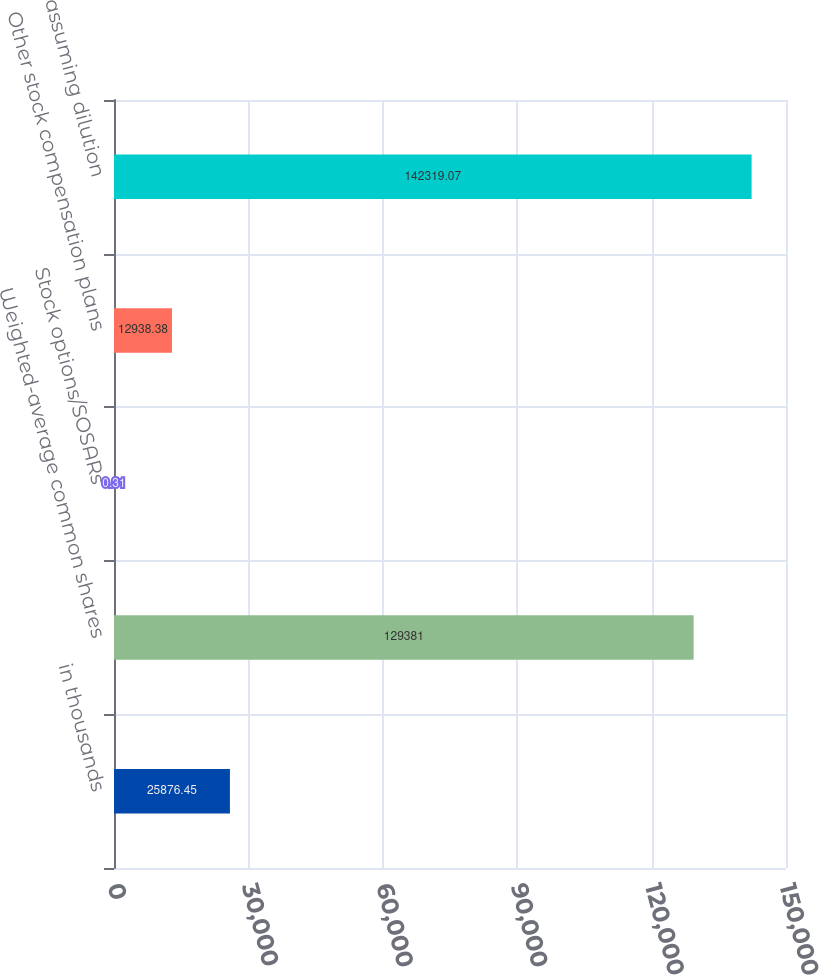Convert chart. <chart><loc_0><loc_0><loc_500><loc_500><bar_chart><fcel>in thousands<fcel>Weighted-average common shares<fcel>Stock options/SOSARs<fcel>Other stock compensation plans<fcel>assuming dilution<nl><fcel>25876.5<fcel>129381<fcel>0.31<fcel>12938.4<fcel>142319<nl></chart> 